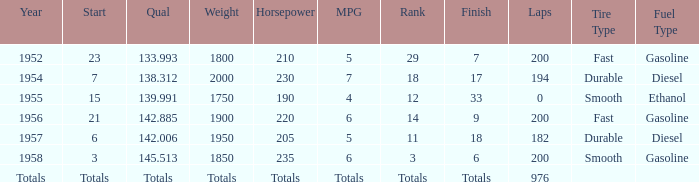What place did Jimmy Reece start from when he ranked 12? 15.0. 